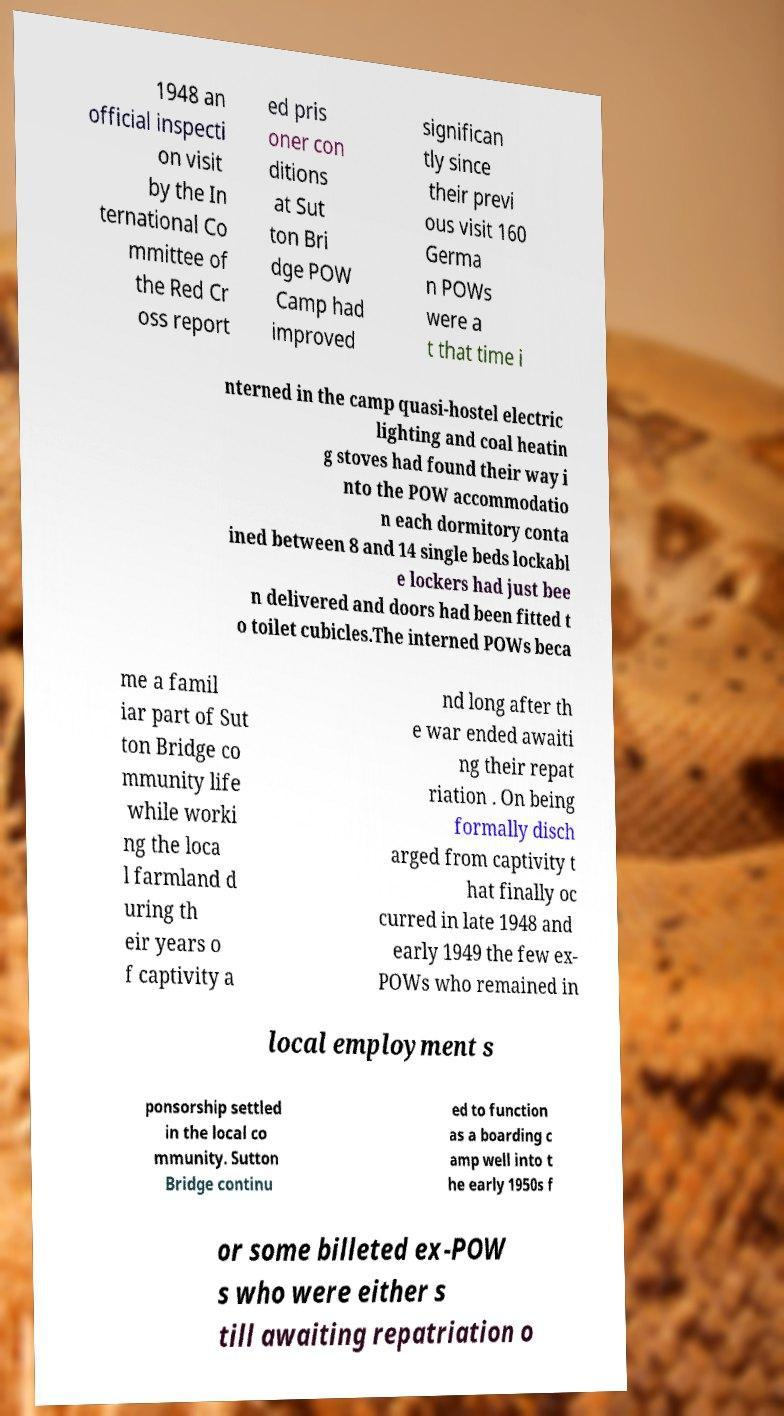Could you extract and type out the text from this image? 1948 an official inspecti on visit by the In ternational Co mmittee of the Red Cr oss report ed pris oner con ditions at Sut ton Bri dge POW Camp had improved significan tly since their previ ous visit 160 Germa n POWs were a t that time i nterned in the camp quasi-hostel electric lighting and coal heatin g stoves had found their way i nto the POW accommodatio n each dormitory conta ined between 8 and 14 single beds lockabl e lockers had just bee n delivered and doors had been fitted t o toilet cubicles.The interned POWs beca me a famil iar part of Sut ton Bridge co mmunity life while worki ng the loca l farmland d uring th eir years o f captivity a nd long after th e war ended awaiti ng their repat riation . On being formally disch arged from captivity t hat finally oc curred in late 1948 and early 1949 the few ex- POWs who remained in local employment s ponsorship settled in the local co mmunity. Sutton Bridge continu ed to function as a boarding c amp well into t he early 1950s f or some billeted ex-POW s who were either s till awaiting repatriation o 